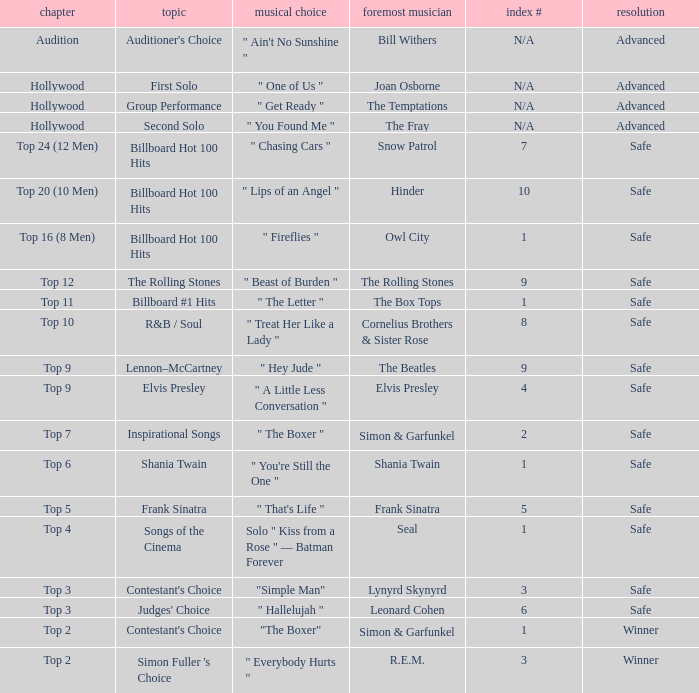Parse the table in full. {'header': ['chapter', 'topic', 'musical choice', 'foremost musician', 'index #', 'resolution'], 'rows': [['Audition', "Auditioner's Choice", '" Ain\'t No Sunshine "', 'Bill Withers', 'N/A', 'Advanced'], ['Hollywood', 'First Solo', '" One of Us "', 'Joan Osborne', 'N/A', 'Advanced'], ['Hollywood', 'Group Performance', '" Get Ready "', 'The Temptations', 'N/A', 'Advanced'], ['Hollywood', 'Second Solo', '" You Found Me "', 'The Fray', 'N/A', 'Advanced'], ['Top 24 (12 Men)', 'Billboard Hot 100 Hits', '" Chasing Cars "', 'Snow Patrol', '7', 'Safe'], ['Top 20 (10 Men)', 'Billboard Hot 100 Hits', '" Lips of an Angel "', 'Hinder', '10', 'Safe'], ['Top 16 (8 Men)', 'Billboard Hot 100 Hits', '" Fireflies "', 'Owl City', '1', 'Safe'], ['Top 12', 'The Rolling Stones', '" Beast of Burden "', 'The Rolling Stones', '9', 'Safe'], ['Top 11', 'Billboard #1 Hits', '" The Letter "', 'The Box Tops', '1', 'Safe'], ['Top 10', 'R&B / Soul', '" Treat Her Like a Lady "', 'Cornelius Brothers & Sister Rose', '8', 'Safe'], ['Top 9', 'Lennon–McCartney', '" Hey Jude "', 'The Beatles', '9', 'Safe'], ['Top 9', 'Elvis Presley', '" A Little Less Conversation "', 'Elvis Presley', '4', 'Safe'], ['Top 7', 'Inspirational Songs', '" The Boxer "', 'Simon & Garfunkel', '2', 'Safe'], ['Top 6', 'Shania Twain', '" You\'re Still the One "', 'Shania Twain', '1', 'Safe'], ['Top 5', 'Frank Sinatra', '" That\'s Life "', 'Frank Sinatra', '5', 'Safe'], ['Top 4', 'Songs of the Cinema', 'Solo " Kiss from a Rose " — Batman Forever', 'Seal', '1', 'Safe'], ['Top 3', "Contestant's Choice", '"Simple Man"', 'Lynyrd Skynyrd', '3', 'Safe'], ['Top 3', "Judges' Choice", '" Hallelujah "', 'Leonard Cohen', '6', 'Safe'], ['Top 2', "Contestant's Choice", '"The Boxer"', 'Simon & Garfunkel', '1', 'Winner'], ['Top 2', "Simon Fuller 's Choice", '" Everybody Hurts "', 'R.E.M.', '3', 'Winner']]} In which episode is the order number 10? Top 20 (10 Men). 